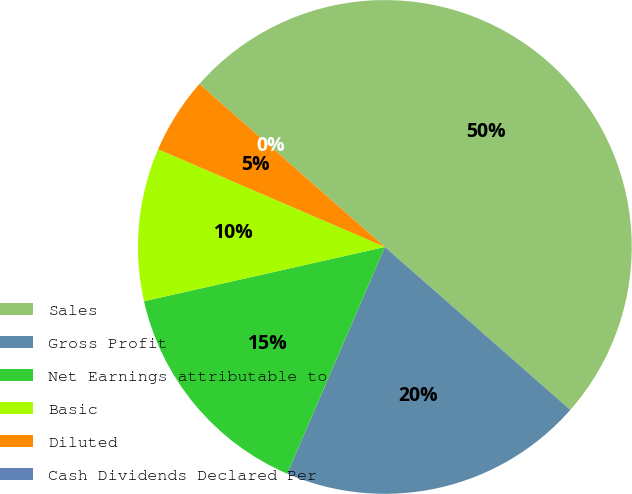Convert chart to OTSL. <chart><loc_0><loc_0><loc_500><loc_500><pie_chart><fcel>Sales<fcel>Gross Profit<fcel>Net Earnings attributable to<fcel>Basic<fcel>Diluted<fcel>Cash Dividends Declared Per<nl><fcel>50.0%<fcel>20.0%<fcel>15.0%<fcel>10.0%<fcel>5.0%<fcel>0.0%<nl></chart> 